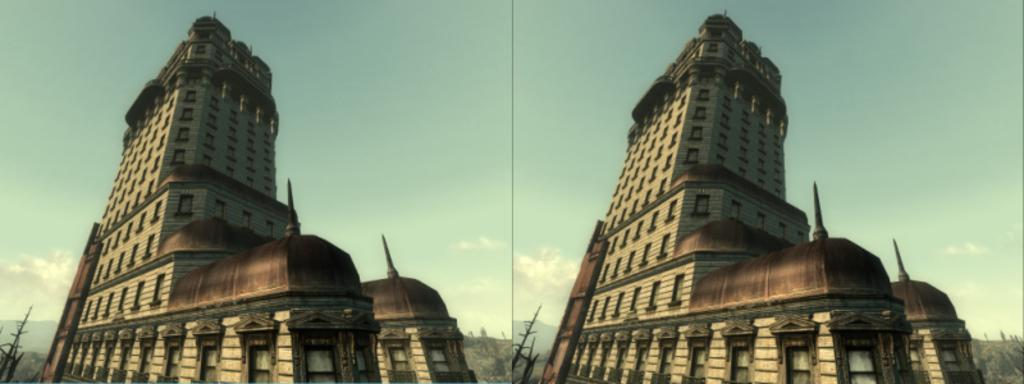What type of artwork is the image? The image is a collage. What type of structures can be seen in the collage? There are buildings in the image. What theory is being discussed in the image? There is no discussion or theory present in the image, as it is a collage of buildings. What calendar is visible in the image? There is no calendar present in the image; it is a collage of buildings. 